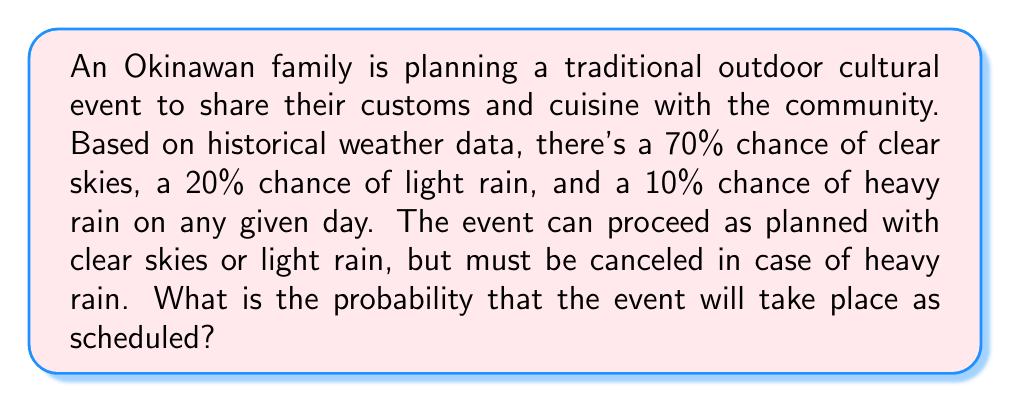Help me with this question. To solve this problem, we need to calculate the probability of favorable weather conditions for the event. Let's break it down step-by-step:

1. Identify the favorable outcomes:
   - Clear skies (70% chance)
   - Light rain (20% chance)

2. Calculate the total probability of favorable outcomes:
   $$P(\text{event takes place}) = P(\text{clear skies}) + P(\text{light rain})$$
   $$P(\text{event takes place}) = 0.70 + 0.20$$
   $$P(\text{event takes place}) = 0.90$$

3. Alternatively, we could have calculated the probability of the event not taking place (heavy rain) and subtracted it from 1:
   $$P(\text{event takes place}) = 1 - P(\text{heavy rain})$$
   $$P(\text{event takes place}) = 1 - 0.10 = 0.90$$

Both methods yield the same result, confirming our calculation.

4. Convert the decimal to a percentage:
   $$0.90 \times 100\% = 90\%$$

Therefore, the probability that the Okinawan family's outdoor cultural event will take place as scheduled is 90% or 0.90.
Answer: The probability that the event will take place as scheduled is $0.90$ or $90\%$. 